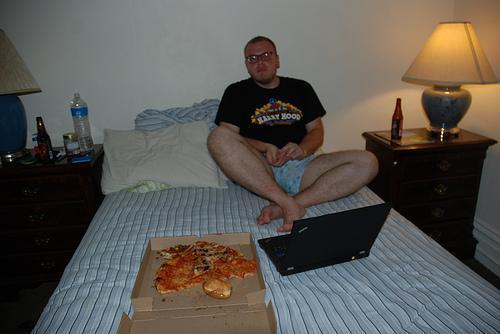How many people?
Give a very brief answer. 1. How many laptops are on the bed?
Give a very brief answer. 1. 